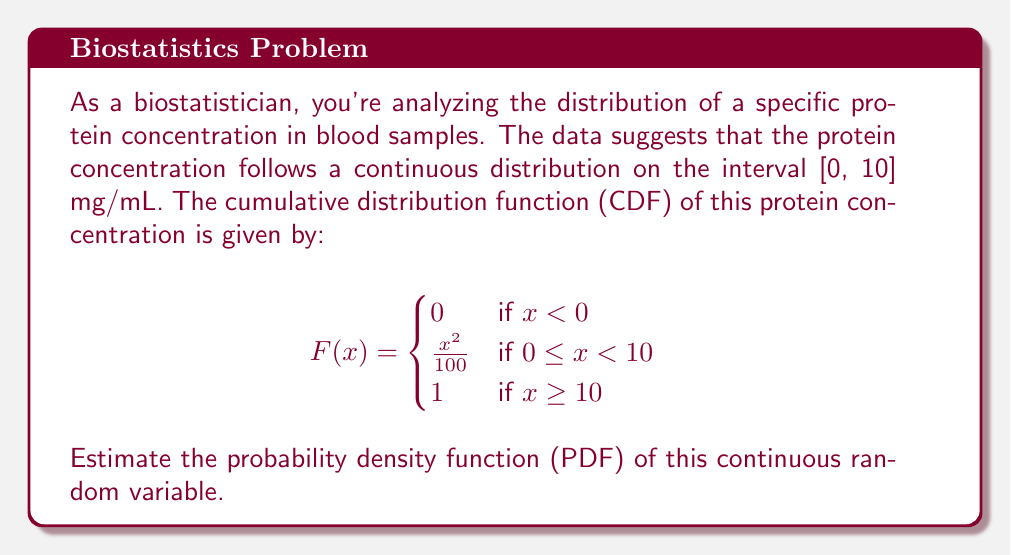Give your solution to this math problem. To estimate the probability density function (PDF) from the given cumulative distribution function (CDF), we need to follow these steps:

1) Recall that the PDF is the derivative of the CDF for continuous random variables:
   $$f(x) = \frac{d}{dx}F(x)$$

2) We need to differentiate each piece of the given CDF:

   For $x < 0$: 
   $$\frac{d}{dx}(0) = 0$$

   For $0 \leq x < 10$:
   $$\frac{d}{dx}(\frac{x^2}{100}) = \frac{2x}{100} = \frac{x}{50}$$

   For $x \geq 10$:
   $$\frac{d}{dx}(1) = 0$$

3) Combining these results, we can express the PDF as:

   $$f(x) = \begin{cases}
   0 & \text{if } x < 0 \\
   \frac{x}{50} & \text{if } 0 \leq x < 10 \\
   0 & \text{if } x \geq 10
   \end{cases}$$

4) To verify, we can check if the PDF integrates to 1 over its domain:

   $$\int_{0}^{10} \frac{x}{50} dx = \frac{1}{50} \left[\frac{x^2}{2}\right]_{0}^{10} = \frac{1}{50} \cdot \frac{100}{2} = 1$$

   This confirms that our derived PDF is valid.
Answer: $$f(x) = \begin{cases}
0 & \text{if } x < 0 \\
\frac{x}{50} & \text{if } 0 \leq x < 10 \\
0 & \text{if } x \geq 10
\end{cases}$$ 